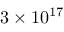<formula> <loc_0><loc_0><loc_500><loc_500>3 \times 1 0 ^ { 1 7 }</formula> 